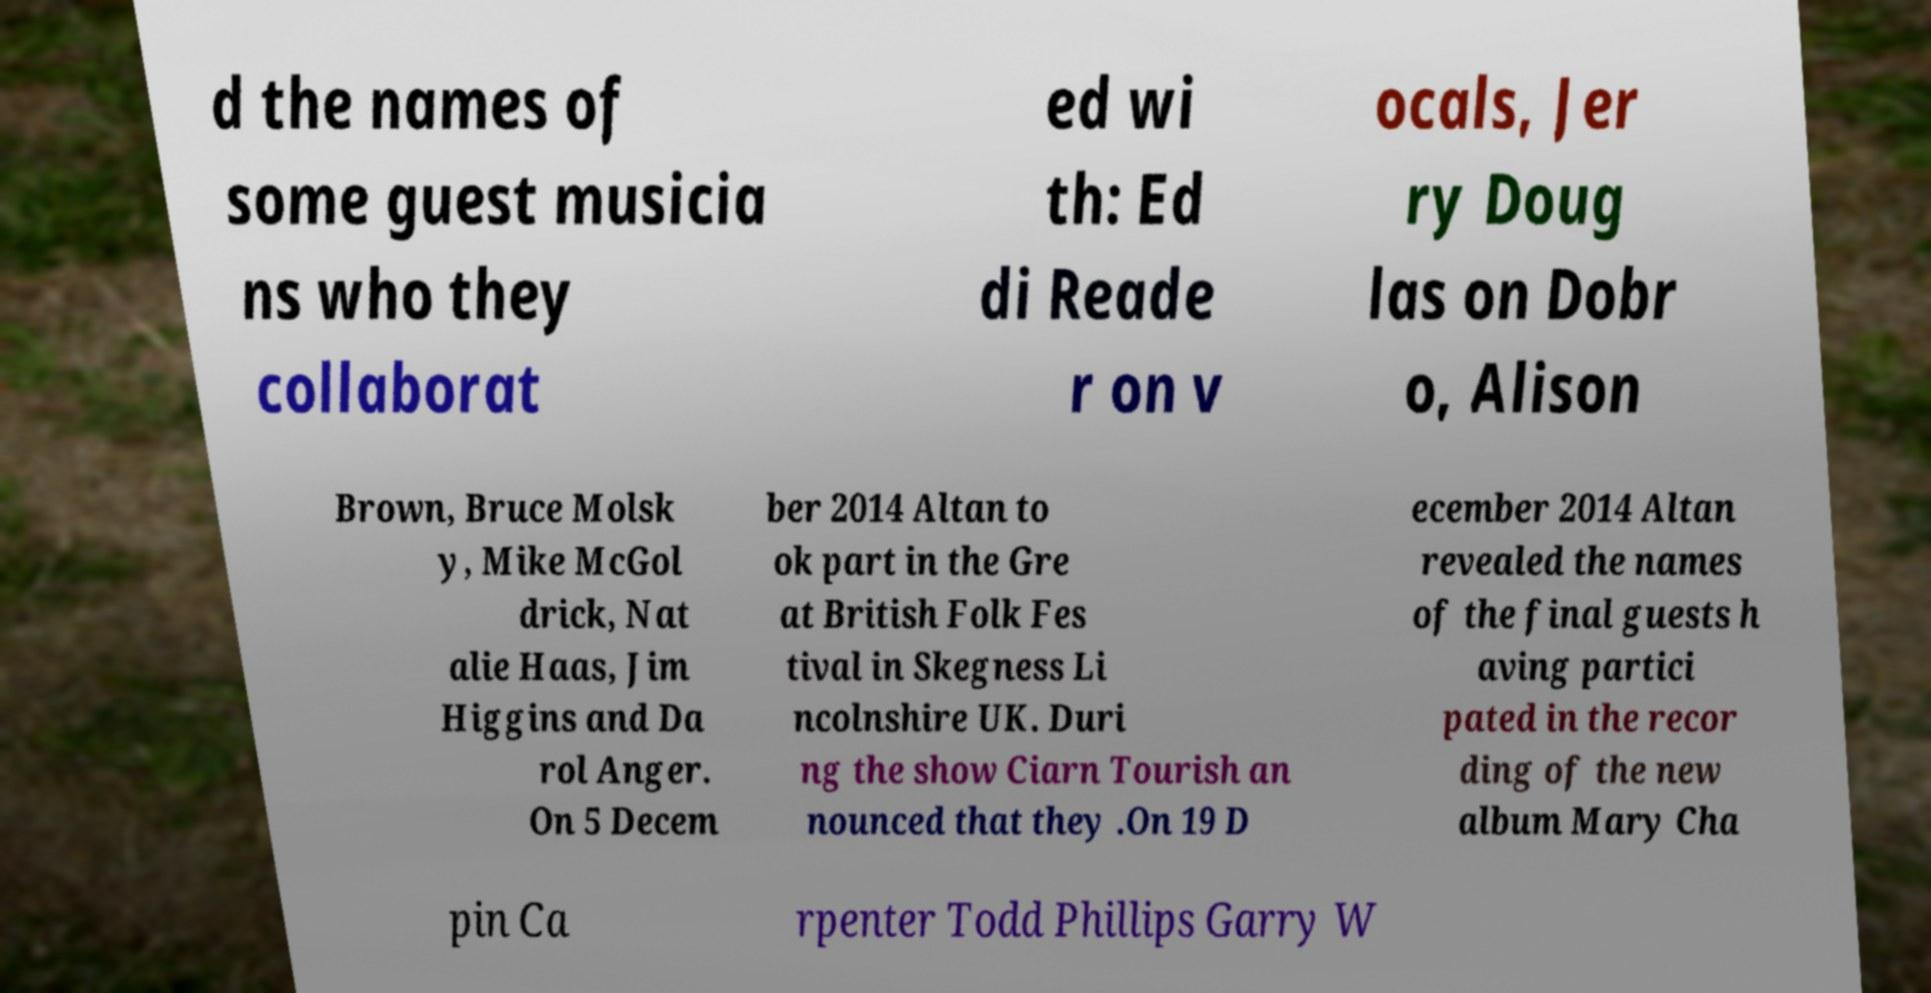Can you read and provide the text displayed in the image?This photo seems to have some interesting text. Can you extract and type it out for me? d the names of some guest musicia ns who they collaborat ed wi th: Ed di Reade r on v ocals, Jer ry Doug las on Dobr o, Alison Brown, Bruce Molsk y, Mike McGol drick, Nat alie Haas, Jim Higgins and Da rol Anger. On 5 Decem ber 2014 Altan to ok part in the Gre at British Folk Fes tival in Skegness Li ncolnshire UK. Duri ng the show Ciarn Tourish an nounced that they .On 19 D ecember 2014 Altan revealed the names of the final guests h aving partici pated in the recor ding of the new album Mary Cha pin Ca rpenter Todd Phillips Garry W 